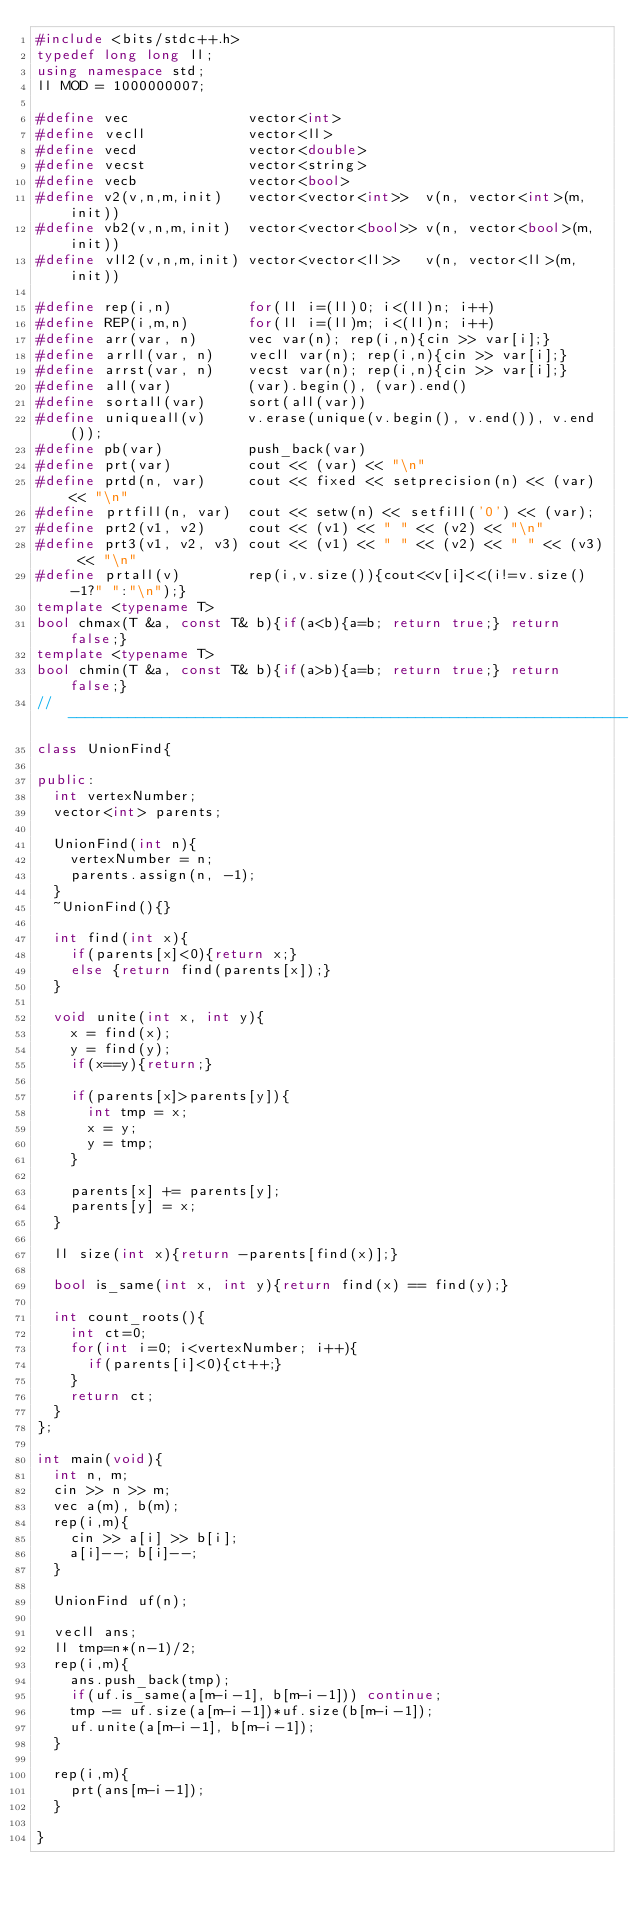<code> <loc_0><loc_0><loc_500><loc_500><_C++_>#include <bits/stdc++.h>
typedef long long ll;
using namespace std;
ll MOD = 1000000007;

#define vec              vector<int>
#define vecll            vector<ll>
#define vecd             vector<double>
#define vecst            vector<string>
#define vecb             vector<bool>
#define v2(v,n,m,init)   vector<vector<int>>  v(n, vector<int>(m, init))
#define vb2(v,n,m,init)  vector<vector<bool>> v(n, vector<bool>(m, init))
#define vll2(v,n,m,init) vector<vector<ll>>   v(n, vector<ll>(m, init))

#define rep(i,n)         for(ll i=(ll)0; i<(ll)n; i++)
#define REP(i,m,n)       for(ll i=(ll)m; i<(ll)n; i++)
#define arr(var, n)      vec var(n); rep(i,n){cin >> var[i];}
#define arrll(var, n)    vecll var(n); rep(i,n){cin >> var[i];}
#define arrst(var, n)    vecst var(n); rep(i,n){cin >> var[i];}
#define all(var)         (var).begin(), (var).end()
#define sortall(var)     sort(all(var))
#define uniqueall(v)     v.erase(unique(v.begin(), v.end()), v.end());
#define pb(var)          push_back(var)
#define prt(var)         cout << (var) << "\n"
#define prtd(n, var)     cout << fixed << setprecision(n) << (var) << "\n"
#define prtfill(n, var)  cout << setw(n) << setfill('0') << (var);
#define prt2(v1, v2)     cout << (v1) << " " << (v2) << "\n"
#define prt3(v1, v2, v3) cout << (v1) << " " << (v2) << " " << (v3) << "\n"
#define prtall(v)        rep(i,v.size()){cout<<v[i]<<(i!=v.size()-1?" ":"\n");}
template <typename T>
bool chmax(T &a, const T& b){if(a<b){a=b; return true;} return false;}
template <typename T>
bool chmin(T &a, const T& b){if(a>b){a=b; return true;} return false;}
//------------------------------------------------------------------
class UnionFind{

public:
  int vertexNumber;
  vector<int> parents;

  UnionFind(int n){
    vertexNumber = n;
    parents.assign(n, -1);
  }
  ~UnionFind(){}

  int find(int x){
    if(parents[x]<0){return x;}
    else {return find(parents[x]);}
  }

  void unite(int x, int y){
    x = find(x);
    y = find(y);
    if(x==y){return;}

    if(parents[x]>parents[y]){
      int tmp = x;
      x = y;
      y = tmp;
    }

    parents[x] += parents[y];
    parents[y] = x;
  }

  ll size(int x){return -parents[find(x)];}

  bool is_same(int x, int y){return find(x) == find(y);}

  int count_roots(){
    int ct=0;
    for(int i=0; i<vertexNumber; i++){
      if(parents[i]<0){ct++;}
    }
    return ct;
  }
};

int main(void){
  int n, m;
  cin >> n >> m;
  vec a(m), b(m);
  rep(i,m){
    cin >> a[i] >> b[i];
    a[i]--; b[i]--;
  }

  UnionFind uf(n);

  vecll ans;
  ll tmp=n*(n-1)/2;
  rep(i,m){
    ans.push_back(tmp);
    if(uf.is_same(a[m-i-1], b[m-i-1])) continue;
    tmp -= uf.size(a[m-i-1])*uf.size(b[m-i-1]);
    uf.unite(a[m-i-1], b[m-i-1]);
  }

  rep(i,m){
    prt(ans[m-i-1]);
  }

}
</code> 